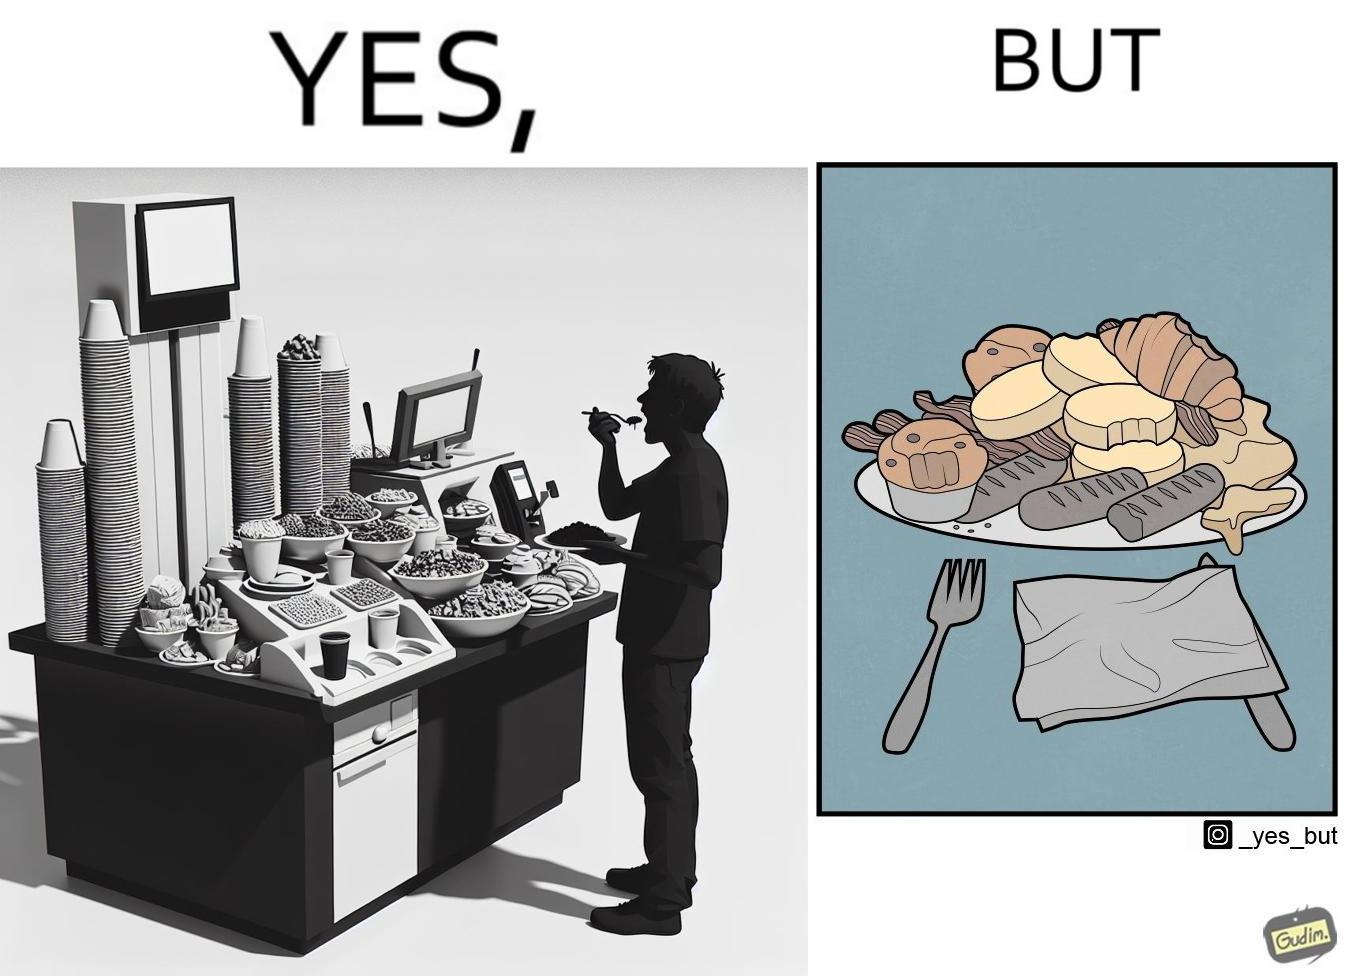Describe the satirical element in this image. The image is satirical because while the man overfils his plate with differnt food items, he ends up wasting almost all of it by not eating them or by taking just one bite out of them leaving the rest. 